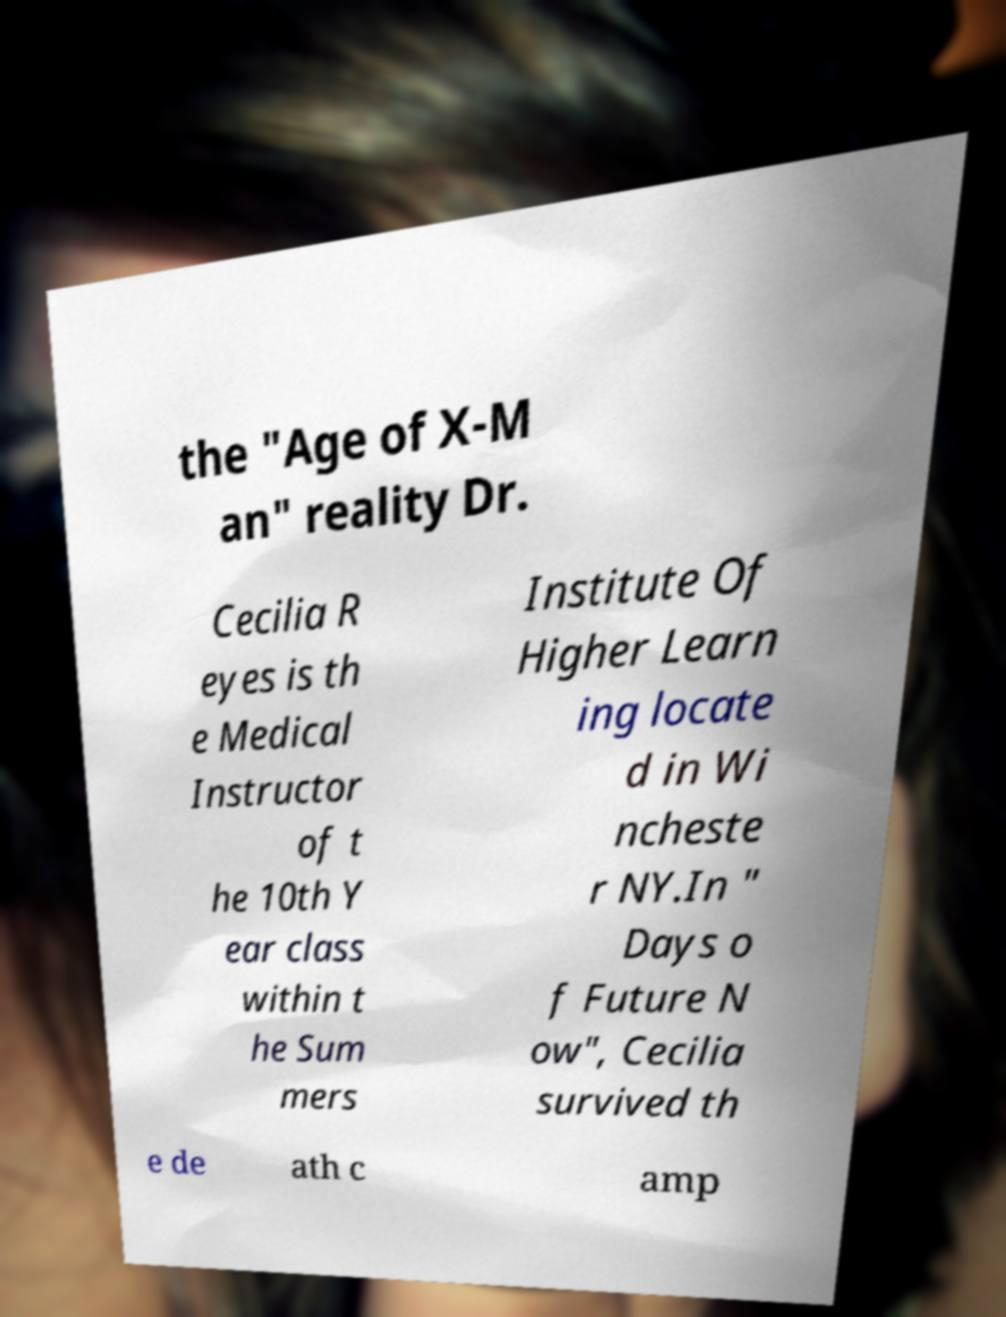Can you accurately transcribe the text from the provided image for me? the "Age of X-M an" reality Dr. Cecilia R eyes is th e Medical Instructor of t he 10th Y ear class within t he Sum mers Institute Of Higher Learn ing locate d in Wi ncheste r NY.In " Days o f Future N ow", Cecilia survived th e de ath c amp 